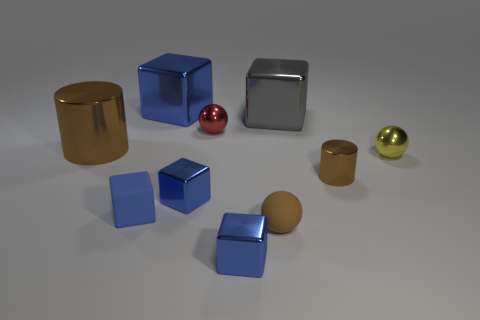There is a tiny shiny sphere to the left of the small yellow thing; what color is it?
Give a very brief answer. Red. Is the number of gray metal objects in front of the brown matte object greater than the number of rubber blocks?
Keep it short and to the point. No. How many other objects are the same size as the gray metal cube?
Provide a short and direct response. 2. What number of brown objects are behind the small blue matte thing?
Your answer should be very brief. 2. Is the number of brown cylinders that are to the right of the yellow metal thing the same as the number of large gray objects that are left of the large cylinder?
Provide a succinct answer. Yes. There is a brown rubber thing that is the same shape as the tiny yellow shiny thing; what size is it?
Your answer should be compact. Small. The small blue metallic object behind the brown ball has what shape?
Your answer should be very brief. Cube. Is the blue block that is behind the yellow metal ball made of the same material as the small brown object on the right side of the large gray block?
Keep it short and to the point. Yes. What is the shape of the large blue object?
Provide a succinct answer. Cube. Is the number of gray things that are in front of the small red shiny ball the same as the number of big brown metallic cylinders?
Provide a succinct answer. No. 